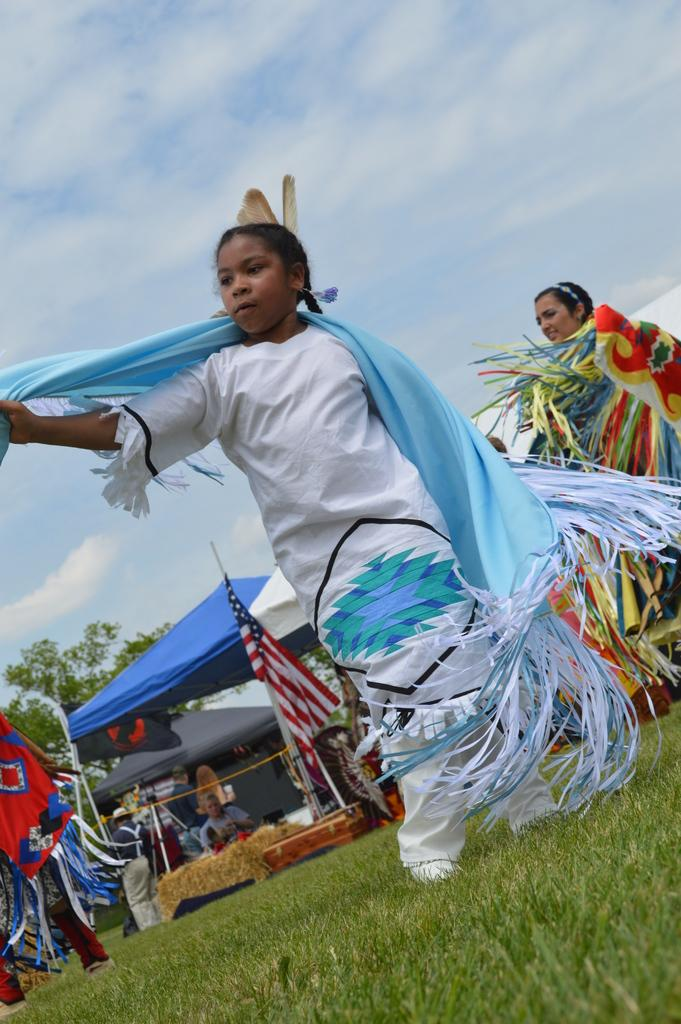What are the people in the image doing? The people in the image are standing on the grass. What can be seen in the background of the image? There is a blue color tent and a green tree visible in the background. How would you describe the sky in the image? The sky is visible and cloudy in the image. What type of alarm can be heard going off in the image? There is no alarm present in the image, so it cannot be heard. --- 